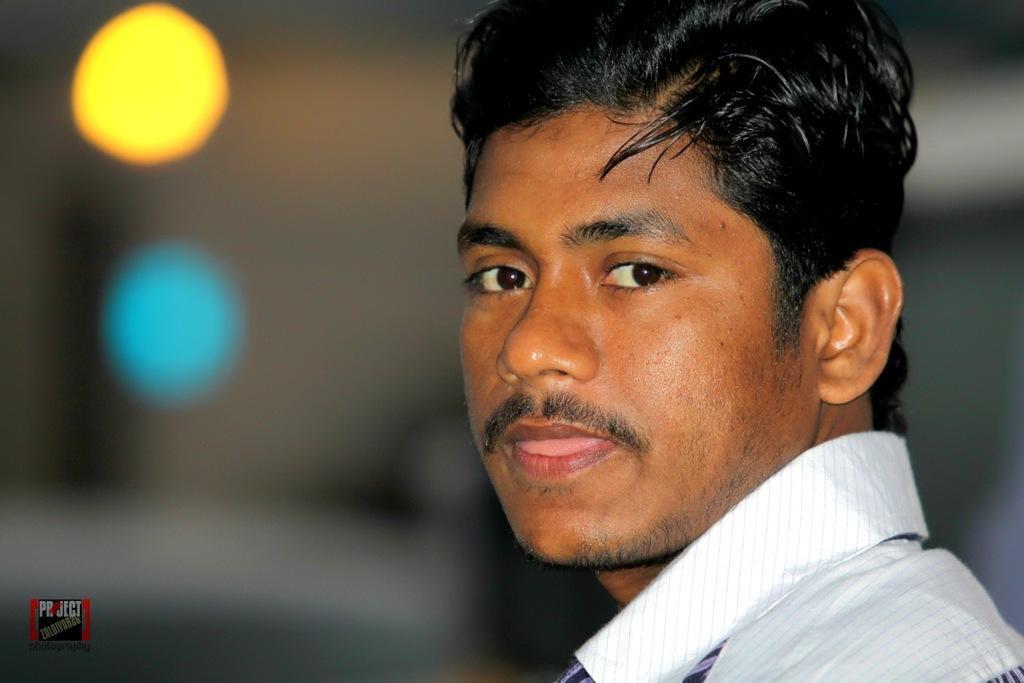Could you give a brief overview of what you see in this image? In this image there is a man , and there is blur background and a watermark on the image. 